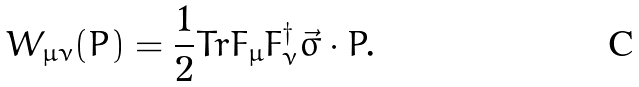Convert formula to latex. <formula><loc_0><loc_0><loc_500><loc_500>W _ { \mu \nu } ( { P } ) = \frac { 1 } { 2 } T r F _ { \mu } F _ { \nu } ^ { \dagger } \vec { \sigma } \cdot { P } .</formula> 